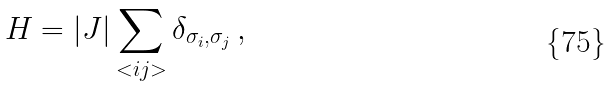Convert formula to latex. <formula><loc_0><loc_0><loc_500><loc_500>H = | J | \sum _ { < i j > } \delta _ { \sigma _ { i } , \sigma _ { j } } \, ,</formula> 